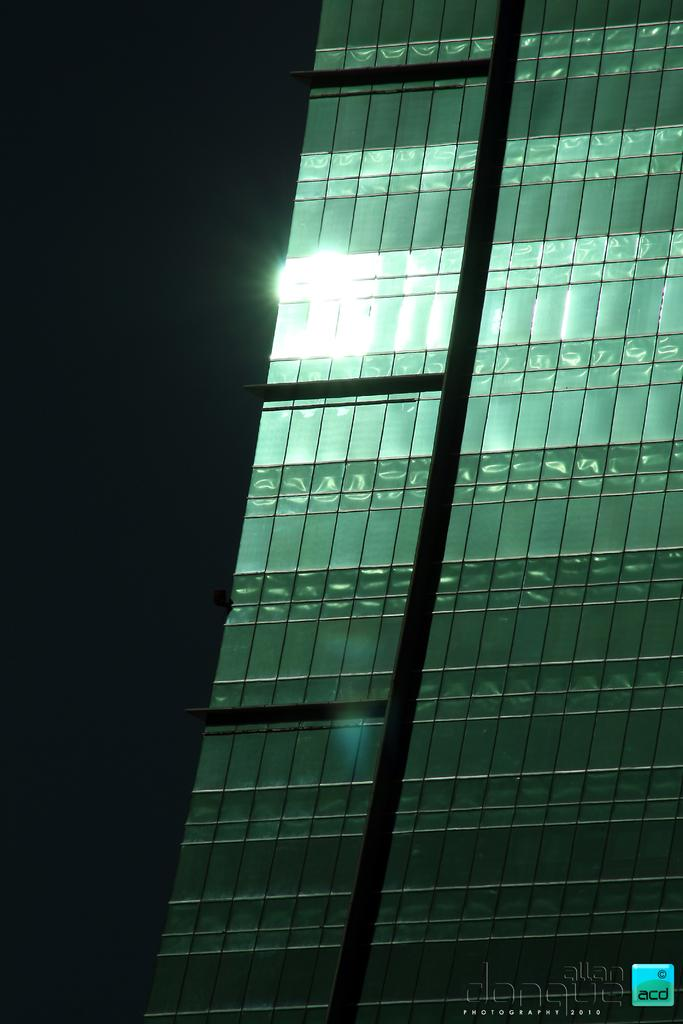What can be seen in the image that allows light to enter? There is a window in the image that allows light to enter. Can you describe the lighting conditions in the image? The image appears to be a little dark, but there is light present. What type of roof can be seen in the image? There is no roof visible in the image; it only shows a window and light. Is the person in the image sleeping? There is no person present in the image, so it is not possible to determine if someone is sleeping. 